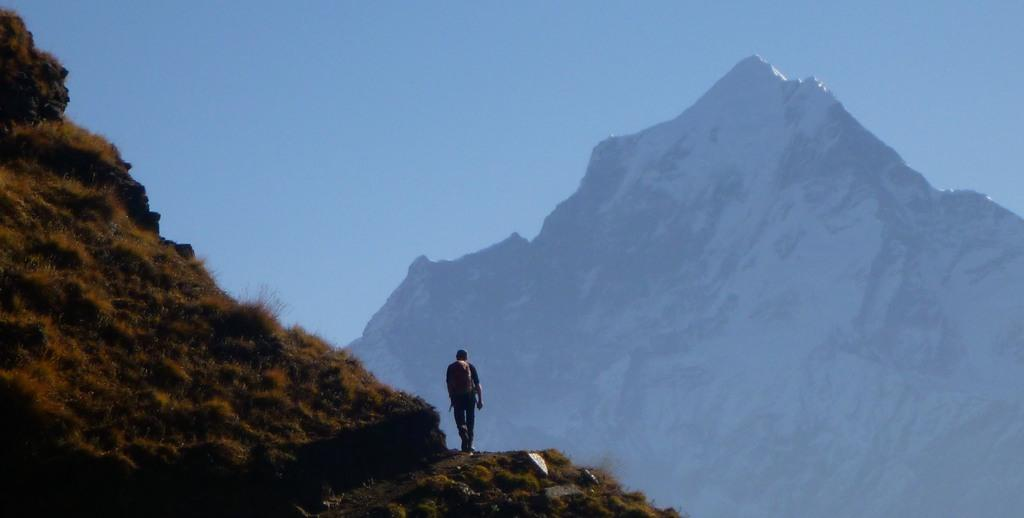What is the main subject in the foreground of the image? There is a man in the foreground of the image. What is the man carrying on his back? The man is wearing a backpack. What type of terrain is the man walking on? The man is walking on a sloped surface. What can be seen in the background of the image? There is a mountain and the sky visible in the background of the image. What type of church can be seen in the image? There is no church present in the image; it features a man walking on a sloped surface with a mountain in the background. How many thumbs does the man have in the image? The number of thumbs the man has cannot be determined from the image. 